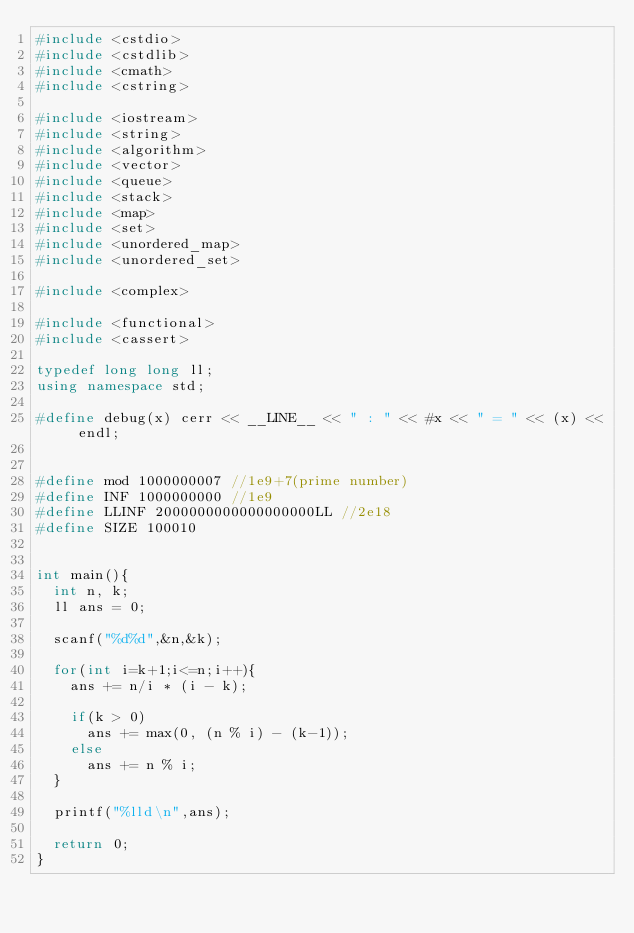Convert code to text. <code><loc_0><loc_0><loc_500><loc_500><_C++_>#include <cstdio>
#include <cstdlib>
#include <cmath>
#include <cstring>

#include <iostream>
#include <string>
#include <algorithm>
#include <vector>
#include <queue>
#include <stack>
#include <map>
#include <set>
#include <unordered_map>
#include <unordered_set>

#include <complex>

#include <functional>
#include <cassert>

typedef long long ll;
using namespace std;

#define debug(x) cerr << __LINE__ << " : " << #x << " = " << (x) << endl;


#define mod 1000000007 //1e9+7(prime number)
#define INF 1000000000 //1e9
#define LLINF 2000000000000000000LL //2e18
#define SIZE 100010


int main(){
  int n, k;
  ll ans = 0;
  
  scanf("%d%d",&n,&k);

  for(int i=k+1;i<=n;i++){
    ans += n/i * (i - k);
    
    if(k > 0)
      ans += max(0, (n % i) - (k-1));
    else
      ans += n % i;    
  }

  printf("%lld\n",ans);
  
  return 0;
}

</code> 